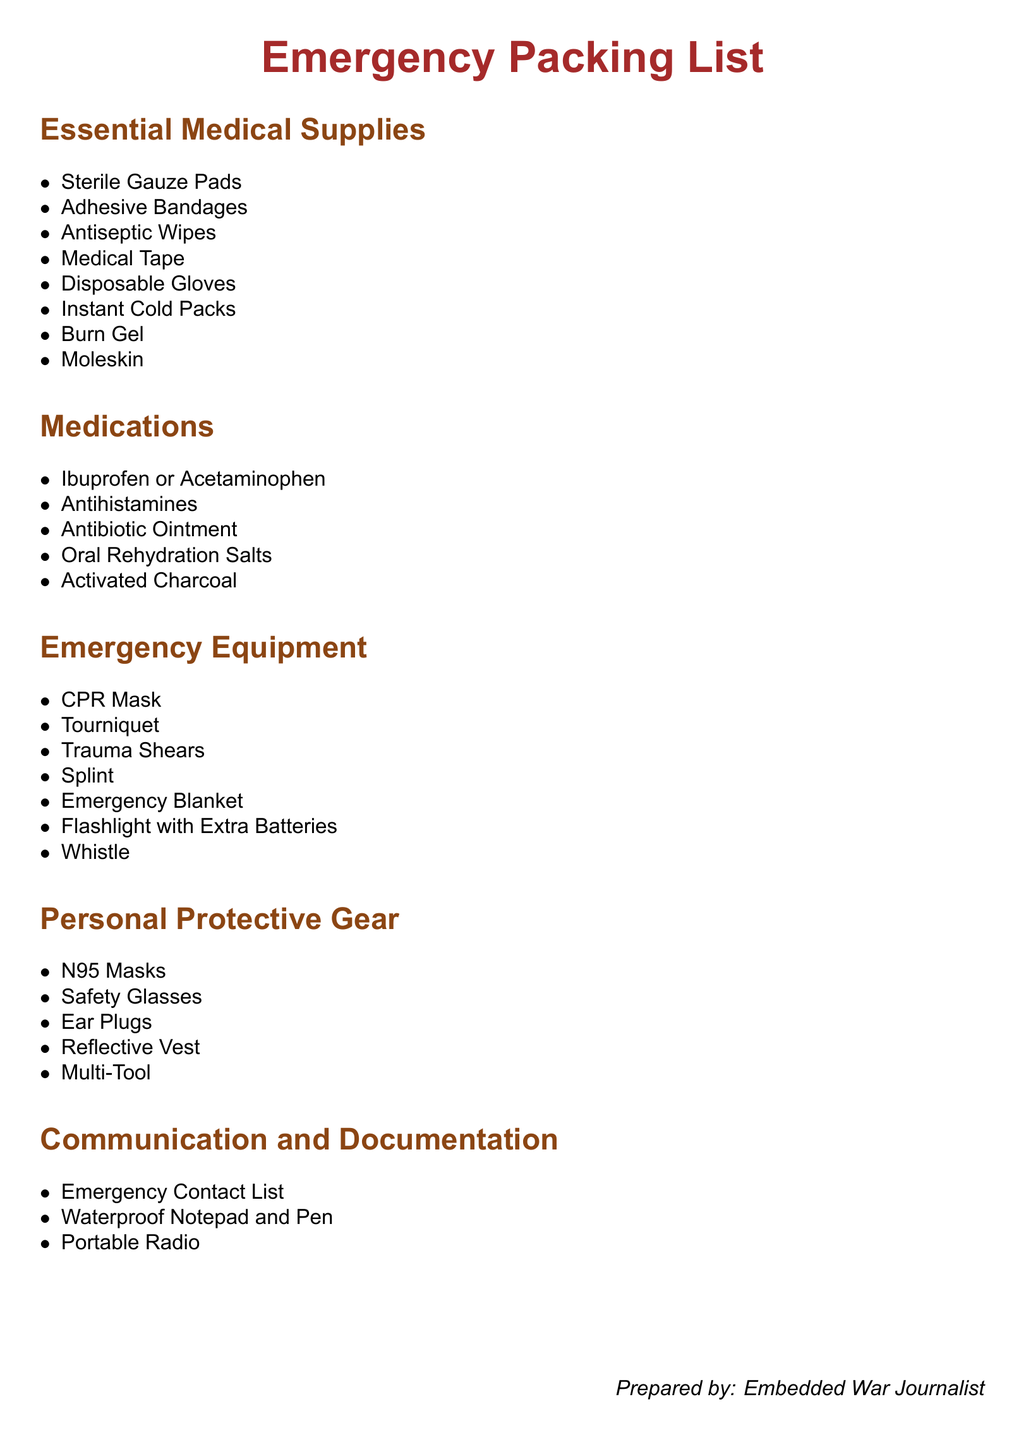what is the first item listed under Essential Medical Supplies? The first item listed in the "Essential Medical Supplies" section of the document is "Sterile Gauze Pads."
Answer: Sterile Gauze Pads how many types of medications are listed in the document? The document lists a total of five types of medications in the "Medications" section.
Answer: 5 what is included in the Emergency Equipment section? The "Emergency Equipment" section includes items like CPR Mask, Tourniquet, and Splint.
Answer: CPR Mask, Tourniquet, Splint which personal protective gear item is mentioned in the document? "N95 Masks" is one of the items listed under the "Personal Protective Gear" section.
Answer: N95 Masks what is the purpose of the waterproof notepad listed in the document? The waterproof notepad is designed for documentation in potentially wet conditions; it allows for writing important information in emergencies.
Answer: Documentation what is the color of the title used in the document? The title "Emergency Packing List" is in a color defined as RGB (165,42,42), which corresponds to a brownish color.
Answer: Brownish how many items are listed under Communication and Documentation? There are three items listed under the "Communication and Documentation" section of the document.
Answer: 3 what is the last item mentioned in the Emergency Equipment section? The last item listed in the "Emergency Equipment" section is "Whistle."
Answer: Whistle 